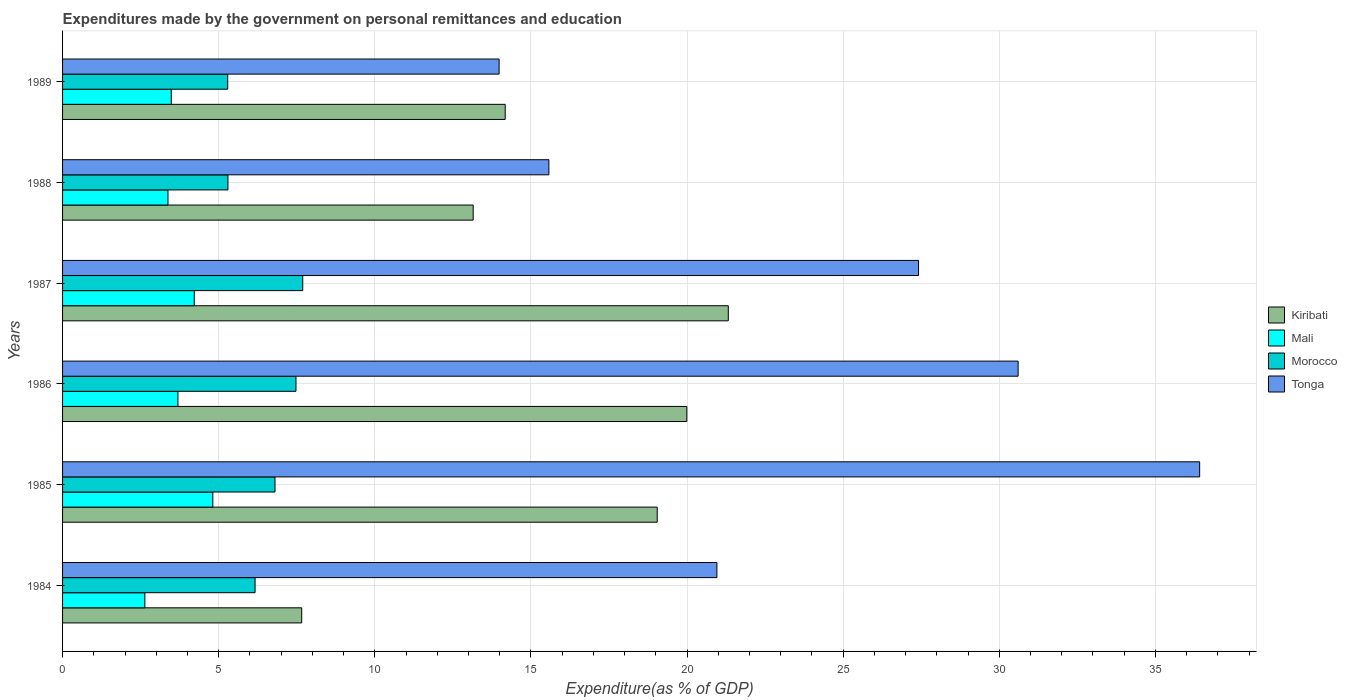How many groups of bars are there?
Your answer should be compact. 6. Are the number of bars per tick equal to the number of legend labels?
Give a very brief answer. Yes. Are the number of bars on each tick of the Y-axis equal?
Your answer should be compact. Yes. How many bars are there on the 2nd tick from the top?
Offer a very short reply. 4. How many bars are there on the 2nd tick from the bottom?
Your answer should be compact. 4. What is the label of the 3rd group of bars from the top?
Offer a terse response. 1987. What is the expenditures made by the government on personal remittances and education in Morocco in 1987?
Ensure brevity in your answer.  7.69. Across all years, what is the maximum expenditures made by the government on personal remittances and education in Mali?
Your answer should be compact. 4.81. Across all years, what is the minimum expenditures made by the government on personal remittances and education in Morocco?
Give a very brief answer. 5.29. In which year was the expenditures made by the government on personal remittances and education in Kiribati minimum?
Keep it short and to the point. 1984. What is the total expenditures made by the government on personal remittances and education in Mali in the graph?
Provide a short and direct response. 22.22. What is the difference between the expenditures made by the government on personal remittances and education in Kiribati in 1987 and that in 1989?
Keep it short and to the point. 7.14. What is the difference between the expenditures made by the government on personal remittances and education in Kiribati in 1988 and the expenditures made by the government on personal remittances and education in Mali in 1986?
Ensure brevity in your answer.  9.46. What is the average expenditures made by the government on personal remittances and education in Mali per year?
Your answer should be compact. 3.7. In the year 1986, what is the difference between the expenditures made by the government on personal remittances and education in Kiribati and expenditures made by the government on personal remittances and education in Morocco?
Make the answer very short. 12.52. In how many years, is the expenditures made by the government on personal remittances and education in Kiribati greater than 31 %?
Your answer should be very brief. 0. What is the ratio of the expenditures made by the government on personal remittances and education in Mali in 1986 to that in 1987?
Provide a succinct answer. 0.88. What is the difference between the highest and the second highest expenditures made by the government on personal remittances and education in Kiribati?
Your answer should be compact. 1.33. What is the difference between the highest and the lowest expenditures made by the government on personal remittances and education in Kiribati?
Make the answer very short. 13.66. What does the 2nd bar from the top in 1987 represents?
Provide a succinct answer. Morocco. What does the 1st bar from the bottom in 1986 represents?
Offer a very short reply. Kiribati. Are all the bars in the graph horizontal?
Your answer should be compact. Yes. How many years are there in the graph?
Keep it short and to the point. 6. Are the values on the major ticks of X-axis written in scientific E-notation?
Give a very brief answer. No. Does the graph contain any zero values?
Provide a short and direct response. No. Does the graph contain grids?
Offer a terse response. Yes. How many legend labels are there?
Your response must be concise. 4. How are the legend labels stacked?
Provide a succinct answer. Vertical. What is the title of the graph?
Keep it short and to the point. Expenditures made by the government on personal remittances and education. What is the label or title of the X-axis?
Ensure brevity in your answer.  Expenditure(as % of GDP). What is the Expenditure(as % of GDP) of Kiribati in 1984?
Ensure brevity in your answer.  7.66. What is the Expenditure(as % of GDP) in Mali in 1984?
Make the answer very short. 2.64. What is the Expenditure(as % of GDP) in Morocco in 1984?
Offer a terse response. 6.17. What is the Expenditure(as % of GDP) of Tonga in 1984?
Keep it short and to the point. 20.96. What is the Expenditure(as % of GDP) of Kiribati in 1985?
Give a very brief answer. 19.04. What is the Expenditure(as % of GDP) of Mali in 1985?
Make the answer very short. 4.81. What is the Expenditure(as % of GDP) of Morocco in 1985?
Your response must be concise. 6.8. What is the Expenditure(as % of GDP) in Tonga in 1985?
Make the answer very short. 36.42. What is the Expenditure(as % of GDP) of Kiribati in 1986?
Provide a succinct answer. 19.99. What is the Expenditure(as % of GDP) in Mali in 1986?
Give a very brief answer. 3.69. What is the Expenditure(as % of GDP) in Morocco in 1986?
Your answer should be compact. 7.48. What is the Expenditure(as % of GDP) of Tonga in 1986?
Make the answer very short. 30.6. What is the Expenditure(as % of GDP) of Kiribati in 1987?
Offer a terse response. 21.32. What is the Expenditure(as % of GDP) in Mali in 1987?
Make the answer very short. 4.22. What is the Expenditure(as % of GDP) of Morocco in 1987?
Offer a very short reply. 7.69. What is the Expenditure(as % of GDP) of Tonga in 1987?
Make the answer very short. 27.41. What is the Expenditure(as % of GDP) of Kiribati in 1988?
Provide a succinct answer. 13.15. What is the Expenditure(as % of GDP) in Mali in 1988?
Your answer should be compact. 3.38. What is the Expenditure(as % of GDP) of Morocco in 1988?
Ensure brevity in your answer.  5.3. What is the Expenditure(as % of GDP) of Tonga in 1988?
Your response must be concise. 15.58. What is the Expenditure(as % of GDP) of Kiribati in 1989?
Provide a succinct answer. 14.18. What is the Expenditure(as % of GDP) of Mali in 1989?
Your answer should be very brief. 3.48. What is the Expenditure(as % of GDP) in Morocco in 1989?
Give a very brief answer. 5.29. What is the Expenditure(as % of GDP) of Tonga in 1989?
Give a very brief answer. 13.98. Across all years, what is the maximum Expenditure(as % of GDP) in Kiribati?
Your response must be concise. 21.32. Across all years, what is the maximum Expenditure(as % of GDP) in Mali?
Offer a very short reply. 4.81. Across all years, what is the maximum Expenditure(as % of GDP) in Morocco?
Offer a terse response. 7.69. Across all years, what is the maximum Expenditure(as % of GDP) of Tonga?
Your answer should be compact. 36.42. Across all years, what is the minimum Expenditure(as % of GDP) in Kiribati?
Provide a succinct answer. 7.66. Across all years, what is the minimum Expenditure(as % of GDP) of Mali?
Provide a succinct answer. 2.64. Across all years, what is the minimum Expenditure(as % of GDP) in Morocco?
Offer a terse response. 5.29. Across all years, what is the minimum Expenditure(as % of GDP) of Tonga?
Provide a short and direct response. 13.98. What is the total Expenditure(as % of GDP) in Kiribati in the graph?
Your response must be concise. 95.34. What is the total Expenditure(as % of GDP) of Mali in the graph?
Give a very brief answer. 22.22. What is the total Expenditure(as % of GDP) in Morocco in the graph?
Your answer should be very brief. 38.72. What is the total Expenditure(as % of GDP) in Tonga in the graph?
Your answer should be compact. 144.95. What is the difference between the Expenditure(as % of GDP) of Kiribati in 1984 and that in 1985?
Ensure brevity in your answer.  -11.39. What is the difference between the Expenditure(as % of GDP) of Mali in 1984 and that in 1985?
Your answer should be very brief. -2.18. What is the difference between the Expenditure(as % of GDP) in Morocco in 1984 and that in 1985?
Keep it short and to the point. -0.64. What is the difference between the Expenditure(as % of GDP) in Tonga in 1984 and that in 1985?
Ensure brevity in your answer.  -15.46. What is the difference between the Expenditure(as % of GDP) in Kiribati in 1984 and that in 1986?
Ensure brevity in your answer.  -12.33. What is the difference between the Expenditure(as % of GDP) of Mali in 1984 and that in 1986?
Ensure brevity in your answer.  -1.06. What is the difference between the Expenditure(as % of GDP) in Morocco in 1984 and that in 1986?
Give a very brief answer. -1.31. What is the difference between the Expenditure(as % of GDP) of Tonga in 1984 and that in 1986?
Ensure brevity in your answer.  -9.65. What is the difference between the Expenditure(as % of GDP) in Kiribati in 1984 and that in 1987?
Provide a succinct answer. -13.66. What is the difference between the Expenditure(as % of GDP) of Mali in 1984 and that in 1987?
Make the answer very short. -1.58. What is the difference between the Expenditure(as % of GDP) in Morocco in 1984 and that in 1987?
Give a very brief answer. -1.53. What is the difference between the Expenditure(as % of GDP) in Tonga in 1984 and that in 1987?
Provide a succinct answer. -6.46. What is the difference between the Expenditure(as % of GDP) in Kiribati in 1984 and that in 1988?
Give a very brief answer. -5.49. What is the difference between the Expenditure(as % of GDP) of Mali in 1984 and that in 1988?
Provide a succinct answer. -0.74. What is the difference between the Expenditure(as % of GDP) of Morocco in 1984 and that in 1988?
Offer a very short reply. 0.87. What is the difference between the Expenditure(as % of GDP) in Tonga in 1984 and that in 1988?
Provide a succinct answer. 5.38. What is the difference between the Expenditure(as % of GDP) of Kiribati in 1984 and that in 1989?
Provide a short and direct response. -6.52. What is the difference between the Expenditure(as % of GDP) of Mali in 1984 and that in 1989?
Provide a succinct answer. -0.85. What is the difference between the Expenditure(as % of GDP) in Morocco in 1984 and that in 1989?
Give a very brief answer. 0.88. What is the difference between the Expenditure(as % of GDP) in Tonga in 1984 and that in 1989?
Your response must be concise. 6.98. What is the difference between the Expenditure(as % of GDP) of Kiribati in 1985 and that in 1986?
Keep it short and to the point. -0.95. What is the difference between the Expenditure(as % of GDP) in Mali in 1985 and that in 1986?
Offer a very short reply. 1.12. What is the difference between the Expenditure(as % of GDP) of Morocco in 1985 and that in 1986?
Keep it short and to the point. -0.67. What is the difference between the Expenditure(as % of GDP) of Tonga in 1985 and that in 1986?
Give a very brief answer. 5.81. What is the difference between the Expenditure(as % of GDP) of Kiribati in 1985 and that in 1987?
Your answer should be compact. -2.28. What is the difference between the Expenditure(as % of GDP) of Mali in 1985 and that in 1987?
Your answer should be compact. 0.59. What is the difference between the Expenditure(as % of GDP) in Morocco in 1985 and that in 1987?
Make the answer very short. -0.89. What is the difference between the Expenditure(as % of GDP) of Tonga in 1985 and that in 1987?
Keep it short and to the point. 9. What is the difference between the Expenditure(as % of GDP) of Kiribati in 1985 and that in 1988?
Your answer should be compact. 5.89. What is the difference between the Expenditure(as % of GDP) of Mali in 1985 and that in 1988?
Make the answer very short. 1.44. What is the difference between the Expenditure(as % of GDP) of Morocco in 1985 and that in 1988?
Your answer should be compact. 1.51. What is the difference between the Expenditure(as % of GDP) in Tonga in 1985 and that in 1988?
Offer a terse response. 20.84. What is the difference between the Expenditure(as % of GDP) in Kiribati in 1985 and that in 1989?
Your answer should be very brief. 4.87. What is the difference between the Expenditure(as % of GDP) of Mali in 1985 and that in 1989?
Provide a short and direct response. 1.33. What is the difference between the Expenditure(as % of GDP) of Morocco in 1985 and that in 1989?
Keep it short and to the point. 1.51. What is the difference between the Expenditure(as % of GDP) of Tonga in 1985 and that in 1989?
Ensure brevity in your answer.  22.44. What is the difference between the Expenditure(as % of GDP) in Kiribati in 1986 and that in 1987?
Your answer should be very brief. -1.33. What is the difference between the Expenditure(as % of GDP) in Mali in 1986 and that in 1987?
Offer a terse response. -0.52. What is the difference between the Expenditure(as % of GDP) in Morocco in 1986 and that in 1987?
Provide a succinct answer. -0.22. What is the difference between the Expenditure(as % of GDP) of Tonga in 1986 and that in 1987?
Your answer should be very brief. 3.19. What is the difference between the Expenditure(as % of GDP) in Kiribati in 1986 and that in 1988?
Offer a terse response. 6.84. What is the difference between the Expenditure(as % of GDP) of Mali in 1986 and that in 1988?
Offer a terse response. 0.32. What is the difference between the Expenditure(as % of GDP) in Morocco in 1986 and that in 1988?
Make the answer very short. 2.18. What is the difference between the Expenditure(as % of GDP) in Tonga in 1986 and that in 1988?
Offer a terse response. 15.03. What is the difference between the Expenditure(as % of GDP) in Kiribati in 1986 and that in 1989?
Ensure brevity in your answer.  5.82. What is the difference between the Expenditure(as % of GDP) in Mali in 1986 and that in 1989?
Keep it short and to the point. 0.21. What is the difference between the Expenditure(as % of GDP) of Morocco in 1986 and that in 1989?
Offer a very short reply. 2.19. What is the difference between the Expenditure(as % of GDP) of Tonga in 1986 and that in 1989?
Offer a very short reply. 16.62. What is the difference between the Expenditure(as % of GDP) in Kiribati in 1987 and that in 1988?
Your response must be concise. 8.17. What is the difference between the Expenditure(as % of GDP) of Mali in 1987 and that in 1988?
Provide a short and direct response. 0.84. What is the difference between the Expenditure(as % of GDP) in Morocco in 1987 and that in 1988?
Your response must be concise. 2.4. What is the difference between the Expenditure(as % of GDP) of Tonga in 1987 and that in 1988?
Give a very brief answer. 11.84. What is the difference between the Expenditure(as % of GDP) in Kiribati in 1987 and that in 1989?
Keep it short and to the point. 7.14. What is the difference between the Expenditure(as % of GDP) in Mali in 1987 and that in 1989?
Give a very brief answer. 0.74. What is the difference between the Expenditure(as % of GDP) in Morocco in 1987 and that in 1989?
Make the answer very short. 2.4. What is the difference between the Expenditure(as % of GDP) of Tonga in 1987 and that in 1989?
Provide a succinct answer. 13.43. What is the difference between the Expenditure(as % of GDP) of Kiribati in 1988 and that in 1989?
Offer a terse response. -1.03. What is the difference between the Expenditure(as % of GDP) in Mali in 1988 and that in 1989?
Provide a succinct answer. -0.11. What is the difference between the Expenditure(as % of GDP) of Morocco in 1988 and that in 1989?
Provide a short and direct response. 0.01. What is the difference between the Expenditure(as % of GDP) of Tonga in 1988 and that in 1989?
Give a very brief answer. 1.59. What is the difference between the Expenditure(as % of GDP) of Kiribati in 1984 and the Expenditure(as % of GDP) of Mali in 1985?
Your answer should be compact. 2.85. What is the difference between the Expenditure(as % of GDP) in Kiribati in 1984 and the Expenditure(as % of GDP) in Morocco in 1985?
Ensure brevity in your answer.  0.85. What is the difference between the Expenditure(as % of GDP) in Kiribati in 1984 and the Expenditure(as % of GDP) in Tonga in 1985?
Offer a terse response. -28.76. What is the difference between the Expenditure(as % of GDP) in Mali in 1984 and the Expenditure(as % of GDP) in Morocco in 1985?
Offer a terse response. -4.17. What is the difference between the Expenditure(as % of GDP) in Mali in 1984 and the Expenditure(as % of GDP) in Tonga in 1985?
Give a very brief answer. -33.78. What is the difference between the Expenditure(as % of GDP) of Morocco in 1984 and the Expenditure(as % of GDP) of Tonga in 1985?
Your response must be concise. -30.25. What is the difference between the Expenditure(as % of GDP) in Kiribati in 1984 and the Expenditure(as % of GDP) in Mali in 1986?
Ensure brevity in your answer.  3.96. What is the difference between the Expenditure(as % of GDP) of Kiribati in 1984 and the Expenditure(as % of GDP) of Morocco in 1986?
Offer a very short reply. 0.18. What is the difference between the Expenditure(as % of GDP) of Kiribati in 1984 and the Expenditure(as % of GDP) of Tonga in 1986?
Ensure brevity in your answer.  -22.94. What is the difference between the Expenditure(as % of GDP) of Mali in 1984 and the Expenditure(as % of GDP) of Morocco in 1986?
Ensure brevity in your answer.  -4.84. What is the difference between the Expenditure(as % of GDP) of Mali in 1984 and the Expenditure(as % of GDP) of Tonga in 1986?
Your response must be concise. -27.97. What is the difference between the Expenditure(as % of GDP) of Morocco in 1984 and the Expenditure(as % of GDP) of Tonga in 1986?
Provide a succinct answer. -24.44. What is the difference between the Expenditure(as % of GDP) in Kiribati in 1984 and the Expenditure(as % of GDP) in Mali in 1987?
Your answer should be compact. 3.44. What is the difference between the Expenditure(as % of GDP) in Kiribati in 1984 and the Expenditure(as % of GDP) in Morocco in 1987?
Provide a succinct answer. -0.03. What is the difference between the Expenditure(as % of GDP) of Kiribati in 1984 and the Expenditure(as % of GDP) of Tonga in 1987?
Ensure brevity in your answer.  -19.76. What is the difference between the Expenditure(as % of GDP) of Mali in 1984 and the Expenditure(as % of GDP) of Morocco in 1987?
Your answer should be very brief. -5.06. What is the difference between the Expenditure(as % of GDP) in Mali in 1984 and the Expenditure(as % of GDP) in Tonga in 1987?
Your answer should be compact. -24.78. What is the difference between the Expenditure(as % of GDP) of Morocco in 1984 and the Expenditure(as % of GDP) of Tonga in 1987?
Keep it short and to the point. -21.25. What is the difference between the Expenditure(as % of GDP) in Kiribati in 1984 and the Expenditure(as % of GDP) in Mali in 1988?
Your response must be concise. 4.28. What is the difference between the Expenditure(as % of GDP) of Kiribati in 1984 and the Expenditure(as % of GDP) of Morocco in 1988?
Give a very brief answer. 2.36. What is the difference between the Expenditure(as % of GDP) in Kiribati in 1984 and the Expenditure(as % of GDP) in Tonga in 1988?
Keep it short and to the point. -7.92. What is the difference between the Expenditure(as % of GDP) in Mali in 1984 and the Expenditure(as % of GDP) in Morocco in 1988?
Make the answer very short. -2.66. What is the difference between the Expenditure(as % of GDP) in Mali in 1984 and the Expenditure(as % of GDP) in Tonga in 1988?
Keep it short and to the point. -12.94. What is the difference between the Expenditure(as % of GDP) in Morocco in 1984 and the Expenditure(as % of GDP) in Tonga in 1988?
Your answer should be very brief. -9.41. What is the difference between the Expenditure(as % of GDP) in Kiribati in 1984 and the Expenditure(as % of GDP) in Mali in 1989?
Ensure brevity in your answer.  4.18. What is the difference between the Expenditure(as % of GDP) in Kiribati in 1984 and the Expenditure(as % of GDP) in Morocco in 1989?
Your response must be concise. 2.37. What is the difference between the Expenditure(as % of GDP) in Kiribati in 1984 and the Expenditure(as % of GDP) in Tonga in 1989?
Your answer should be compact. -6.32. What is the difference between the Expenditure(as % of GDP) in Mali in 1984 and the Expenditure(as % of GDP) in Morocco in 1989?
Make the answer very short. -2.65. What is the difference between the Expenditure(as % of GDP) of Mali in 1984 and the Expenditure(as % of GDP) of Tonga in 1989?
Offer a very short reply. -11.34. What is the difference between the Expenditure(as % of GDP) in Morocco in 1984 and the Expenditure(as % of GDP) in Tonga in 1989?
Provide a succinct answer. -7.82. What is the difference between the Expenditure(as % of GDP) in Kiribati in 1985 and the Expenditure(as % of GDP) in Mali in 1986?
Provide a short and direct response. 15.35. What is the difference between the Expenditure(as % of GDP) of Kiribati in 1985 and the Expenditure(as % of GDP) of Morocco in 1986?
Give a very brief answer. 11.57. What is the difference between the Expenditure(as % of GDP) in Kiribati in 1985 and the Expenditure(as % of GDP) in Tonga in 1986?
Give a very brief answer. -11.56. What is the difference between the Expenditure(as % of GDP) in Mali in 1985 and the Expenditure(as % of GDP) in Morocco in 1986?
Your answer should be very brief. -2.66. What is the difference between the Expenditure(as % of GDP) of Mali in 1985 and the Expenditure(as % of GDP) of Tonga in 1986?
Ensure brevity in your answer.  -25.79. What is the difference between the Expenditure(as % of GDP) in Morocco in 1985 and the Expenditure(as % of GDP) in Tonga in 1986?
Offer a terse response. -23.8. What is the difference between the Expenditure(as % of GDP) in Kiribati in 1985 and the Expenditure(as % of GDP) in Mali in 1987?
Offer a terse response. 14.83. What is the difference between the Expenditure(as % of GDP) in Kiribati in 1985 and the Expenditure(as % of GDP) in Morocco in 1987?
Provide a short and direct response. 11.35. What is the difference between the Expenditure(as % of GDP) of Kiribati in 1985 and the Expenditure(as % of GDP) of Tonga in 1987?
Provide a short and direct response. -8.37. What is the difference between the Expenditure(as % of GDP) in Mali in 1985 and the Expenditure(as % of GDP) in Morocco in 1987?
Give a very brief answer. -2.88. What is the difference between the Expenditure(as % of GDP) of Mali in 1985 and the Expenditure(as % of GDP) of Tonga in 1987?
Provide a short and direct response. -22.6. What is the difference between the Expenditure(as % of GDP) of Morocco in 1985 and the Expenditure(as % of GDP) of Tonga in 1987?
Offer a terse response. -20.61. What is the difference between the Expenditure(as % of GDP) in Kiribati in 1985 and the Expenditure(as % of GDP) in Mali in 1988?
Your answer should be very brief. 15.67. What is the difference between the Expenditure(as % of GDP) of Kiribati in 1985 and the Expenditure(as % of GDP) of Morocco in 1988?
Provide a short and direct response. 13.75. What is the difference between the Expenditure(as % of GDP) of Kiribati in 1985 and the Expenditure(as % of GDP) of Tonga in 1988?
Make the answer very short. 3.47. What is the difference between the Expenditure(as % of GDP) in Mali in 1985 and the Expenditure(as % of GDP) in Morocco in 1988?
Keep it short and to the point. -0.48. What is the difference between the Expenditure(as % of GDP) in Mali in 1985 and the Expenditure(as % of GDP) in Tonga in 1988?
Ensure brevity in your answer.  -10.76. What is the difference between the Expenditure(as % of GDP) of Morocco in 1985 and the Expenditure(as % of GDP) of Tonga in 1988?
Your answer should be very brief. -8.77. What is the difference between the Expenditure(as % of GDP) in Kiribati in 1985 and the Expenditure(as % of GDP) in Mali in 1989?
Offer a very short reply. 15.56. What is the difference between the Expenditure(as % of GDP) of Kiribati in 1985 and the Expenditure(as % of GDP) of Morocco in 1989?
Your answer should be compact. 13.76. What is the difference between the Expenditure(as % of GDP) of Kiribati in 1985 and the Expenditure(as % of GDP) of Tonga in 1989?
Your answer should be compact. 5.06. What is the difference between the Expenditure(as % of GDP) of Mali in 1985 and the Expenditure(as % of GDP) of Morocco in 1989?
Make the answer very short. -0.48. What is the difference between the Expenditure(as % of GDP) of Mali in 1985 and the Expenditure(as % of GDP) of Tonga in 1989?
Offer a very short reply. -9.17. What is the difference between the Expenditure(as % of GDP) of Morocco in 1985 and the Expenditure(as % of GDP) of Tonga in 1989?
Provide a short and direct response. -7.18. What is the difference between the Expenditure(as % of GDP) of Kiribati in 1986 and the Expenditure(as % of GDP) of Mali in 1987?
Make the answer very short. 15.77. What is the difference between the Expenditure(as % of GDP) in Kiribati in 1986 and the Expenditure(as % of GDP) in Morocco in 1987?
Provide a short and direct response. 12.3. What is the difference between the Expenditure(as % of GDP) of Kiribati in 1986 and the Expenditure(as % of GDP) of Tonga in 1987?
Provide a succinct answer. -7.42. What is the difference between the Expenditure(as % of GDP) in Mali in 1986 and the Expenditure(as % of GDP) in Morocco in 1987?
Give a very brief answer. -4. What is the difference between the Expenditure(as % of GDP) of Mali in 1986 and the Expenditure(as % of GDP) of Tonga in 1987?
Ensure brevity in your answer.  -23.72. What is the difference between the Expenditure(as % of GDP) of Morocco in 1986 and the Expenditure(as % of GDP) of Tonga in 1987?
Give a very brief answer. -19.94. What is the difference between the Expenditure(as % of GDP) in Kiribati in 1986 and the Expenditure(as % of GDP) in Mali in 1988?
Your answer should be compact. 16.62. What is the difference between the Expenditure(as % of GDP) of Kiribati in 1986 and the Expenditure(as % of GDP) of Morocco in 1988?
Your answer should be compact. 14.7. What is the difference between the Expenditure(as % of GDP) in Kiribati in 1986 and the Expenditure(as % of GDP) in Tonga in 1988?
Offer a terse response. 4.42. What is the difference between the Expenditure(as % of GDP) in Mali in 1986 and the Expenditure(as % of GDP) in Morocco in 1988?
Your answer should be very brief. -1.6. What is the difference between the Expenditure(as % of GDP) of Mali in 1986 and the Expenditure(as % of GDP) of Tonga in 1988?
Ensure brevity in your answer.  -11.88. What is the difference between the Expenditure(as % of GDP) in Morocco in 1986 and the Expenditure(as % of GDP) in Tonga in 1988?
Your response must be concise. -8.1. What is the difference between the Expenditure(as % of GDP) in Kiribati in 1986 and the Expenditure(as % of GDP) in Mali in 1989?
Ensure brevity in your answer.  16.51. What is the difference between the Expenditure(as % of GDP) of Kiribati in 1986 and the Expenditure(as % of GDP) of Morocco in 1989?
Make the answer very short. 14.7. What is the difference between the Expenditure(as % of GDP) of Kiribati in 1986 and the Expenditure(as % of GDP) of Tonga in 1989?
Your response must be concise. 6.01. What is the difference between the Expenditure(as % of GDP) in Mali in 1986 and the Expenditure(as % of GDP) in Morocco in 1989?
Ensure brevity in your answer.  -1.59. What is the difference between the Expenditure(as % of GDP) in Mali in 1986 and the Expenditure(as % of GDP) in Tonga in 1989?
Provide a short and direct response. -10.29. What is the difference between the Expenditure(as % of GDP) in Morocco in 1986 and the Expenditure(as % of GDP) in Tonga in 1989?
Give a very brief answer. -6.5. What is the difference between the Expenditure(as % of GDP) in Kiribati in 1987 and the Expenditure(as % of GDP) in Mali in 1988?
Ensure brevity in your answer.  17.94. What is the difference between the Expenditure(as % of GDP) in Kiribati in 1987 and the Expenditure(as % of GDP) in Morocco in 1988?
Offer a very short reply. 16.02. What is the difference between the Expenditure(as % of GDP) of Kiribati in 1987 and the Expenditure(as % of GDP) of Tonga in 1988?
Make the answer very short. 5.75. What is the difference between the Expenditure(as % of GDP) in Mali in 1987 and the Expenditure(as % of GDP) in Morocco in 1988?
Your response must be concise. -1.08. What is the difference between the Expenditure(as % of GDP) of Mali in 1987 and the Expenditure(as % of GDP) of Tonga in 1988?
Your response must be concise. -11.36. What is the difference between the Expenditure(as % of GDP) in Morocco in 1987 and the Expenditure(as % of GDP) in Tonga in 1988?
Make the answer very short. -7.88. What is the difference between the Expenditure(as % of GDP) of Kiribati in 1987 and the Expenditure(as % of GDP) of Mali in 1989?
Offer a very short reply. 17.84. What is the difference between the Expenditure(as % of GDP) in Kiribati in 1987 and the Expenditure(as % of GDP) in Morocco in 1989?
Provide a short and direct response. 16.03. What is the difference between the Expenditure(as % of GDP) of Kiribati in 1987 and the Expenditure(as % of GDP) of Tonga in 1989?
Your answer should be compact. 7.34. What is the difference between the Expenditure(as % of GDP) of Mali in 1987 and the Expenditure(as % of GDP) of Morocco in 1989?
Your answer should be compact. -1.07. What is the difference between the Expenditure(as % of GDP) of Mali in 1987 and the Expenditure(as % of GDP) of Tonga in 1989?
Offer a terse response. -9.76. What is the difference between the Expenditure(as % of GDP) of Morocco in 1987 and the Expenditure(as % of GDP) of Tonga in 1989?
Keep it short and to the point. -6.29. What is the difference between the Expenditure(as % of GDP) in Kiribati in 1988 and the Expenditure(as % of GDP) in Mali in 1989?
Give a very brief answer. 9.67. What is the difference between the Expenditure(as % of GDP) in Kiribati in 1988 and the Expenditure(as % of GDP) in Morocco in 1989?
Provide a succinct answer. 7.86. What is the difference between the Expenditure(as % of GDP) in Kiribati in 1988 and the Expenditure(as % of GDP) in Tonga in 1989?
Keep it short and to the point. -0.83. What is the difference between the Expenditure(as % of GDP) of Mali in 1988 and the Expenditure(as % of GDP) of Morocco in 1989?
Ensure brevity in your answer.  -1.91. What is the difference between the Expenditure(as % of GDP) of Mali in 1988 and the Expenditure(as % of GDP) of Tonga in 1989?
Ensure brevity in your answer.  -10.6. What is the difference between the Expenditure(as % of GDP) of Morocco in 1988 and the Expenditure(as % of GDP) of Tonga in 1989?
Make the answer very short. -8.68. What is the average Expenditure(as % of GDP) in Kiribati per year?
Your answer should be very brief. 15.89. What is the average Expenditure(as % of GDP) of Mali per year?
Offer a very short reply. 3.7. What is the average Expenditure(as % of GDP) in Morocco per year?
Make the answer very short. 6.45. What is the average Expenditure(as % of GDP) of Tonga per year?
Ensure brevity in your answer.  24.16. In the year 1984, what is the difference between the Expenditure(as % of GDP) in Kiribati and Expenditure(as % of GDP) in Mali?
Your answer should be compact. 5.02. In the year 1984, what is the difference between the Expenditure(as % of GDP) of Kiribati and Expenditure(as % of GDP) of Morocco?
Your response must be concise. 1.49. In the year 1984, what is the difference between the Expenditure(as % of GDP) of Kiribati and Expenditure(as % of GDP) of Tonga?
Offer a terse response. -13.3. In the year 1984, what is the difference between the Expenditure(as % of GDP) of Mali and Expenditure(as % of GDP) of Morocco?
Ensure brevity in your answer.  -3.53. In the year 1984, what is the difference between the Expenditure(as % of GDP) in Mali and Expenditure(as % of GDP) in Tonga?
Your answer should be compact. -18.32. In the year 1984, what is the difference between the Expenditure(as % of GDP) in Morocco and Expenditure(as % of GDP) in Tonga?
Provide a short and direct response. -14.79. In the year 1985, what is the difference between the Expenditure(as % of GDP) of Kiribati and Expenditure(as % of GDP) of Mali?
Provide a succinct answer. 14.23. In the year 1985, what is the difference between the Expenditure(as % of GDP) in Kiribati and Expenditure(as % of GDP) in Morocco?
Offer a very short reply. 12.24. In the year 1985, what is the difference between the Expenditure(as % of GDP) of Kiribati and Expenditure(as % of GDP) of Tonga?
Ensure brevity in your answer.  -17.37. In the year 1985, what is the difference between the Expenditure(as % of GDP) of Mali and Expenditure(as % of GDP) of Morocco?
Provide a succinct answer. -1.99. In the year 1985, what is the difference between the Expenditure(as % of GDP) in Mali and Expenditure(as % of GDP) in Tonga?
Offer a very short reply. -31.6. In the year 1985, what is the difference between the Expenditure(as % of GDP) of Morocco and Expenditure(as % of GDP) of Tonga?
Offer a very short reply. -29.61. In the year 1986, what is the difference between the Expenditure(as % of GDP) in Kiribati and Expenditure(as % of GDP) in Mali?
Your answer should be compact. 16.3. In the year 1986, what is the difference between the Expenditure(as % of GDP) in Kiribati and Expenditure(as % of GDP) in Morocco?
Give a very brief answer. 12.52. In the year 1986, what is the difference between the Expenditure(as % of GDP) of Kiribati and Expenditure(as % of GDP) of Tonga?
Provide a short and direct response. -10.61. In the year 1986, what is the difference between the Expenditure(as % of GDP) in Mali and Expenditure(as % of GDP) in Morocco?
Keep it short and to the point. -3.78. In the year 1986, what is the difference between the Expenditure(as % of GDP) in Mali and Expenditure(as % of GDP) in Tonga?
Your answer should be compact. -26.91. In the year 1986, what is the difference between the Expenditure(as % of GDP) in Morocco and Expenditure(as % of GDP) in Tonga?
Provide a short and direct response. -23.13. In the year 1987, what is the difference between the Expenditure(as % of GDP) in Kiribati and Expenditure(as % of GDP) in Mali?
Offer a terse response. 17.1. In the year 1987, what is the difference between the Expenditure(as % of GDP) in Kiribati and Expenditure(as % of GDP) in Morocco?
Provide a succinct answer. 13.63. In the year 1987, what is the difference between the Expenditure(as % of GDP) in Kiribati and Expenditure(as % of GDP) in Tonga?
Offer a very short reply. -6.09. In the year 1987, what is the difference between the Expenditure(as % of GDP) of Mali and Expenditure(as % of GDP) of Morocco?
Your answer should be compact. -3.47. In the year 1987, what is the difference between the Expenditure(as % of GDP) of Mali and Expenditure(as % of GDP) of Tonga?
Offer a very short reply. -23.2. In the year 1987, what is the difference between the Expenditure(as % of GDP) in Morocco and Expenditure(as % of GDP) in Tonga?
Your answer should be compact. -19.72. In the year 1988, what is the difference between the Expenditure(as % of GDP) of Kiribati and Expenditure(as % of GDP) of Mali?
Provide a short and direct response. 9.77. In the year 1988, what is the difference between the Expenditure(as % of GDP) in Kiribati and Expenditure(as % of GDP) in Morocco?
Provide a short and direct response. 7.85. In the year 1988, what is the difference between the Expenditure(as % of GDP) in Kiribati and Expenditure(as % of GDP) in Tonga?
Your answer should be compact. -2.43. In the year 1988, what is the difference between the Expenditure(as % of GDP) in Mali and Expenditure(as % of GDP) in Morocco?
Provide a short and direct response. -1.92. In the year 1988, what is the difference between the Expenditure(as % of GDP) in Mali and Expenditure(as % of GDP) in Tonga?
Give a very brief answer. -12.2. In the year 1988, what is the difference between the Expenditure(as % of GDP) of Morocco and Expenditure(as % of GDP) of Tonga?
Keep it short and to the point. -10.28. In the year 1989, what is the difference between the Expenditure(as % of GDP) in Kiribati and Expenditure(as % of GDP) in Mali?
Provide a short and direct response. 10.69. In the year 1989, what is the difference between the Expenditure(as % of GDP) in Kiribati and Expenditure(as % of GDP) in Morocco?
Your response must be concise. 8.89. In the year 1989, what is the difference between the Expenditure(as % of GDP) of Kiribati and Expenditure(as % of GDP) of Tonga?
Your answer should be compact. 0.2. In the year 1989, what is the difference between the Expenditure(as % of GDP) of Mali and Expenditure(as % of GDP) of Morocco?
Offer a very short reply. -1.81. In the year 1989, what is the difference between the Expenditure(as % of GDP) of Mali and Expenditure(as % of GDP) of Tonga?
Ensure brevity in your answer.  -10.5. In the year 1989, what is the difference between the Expenditure(as % of GDP) in Morocco and Expenditure(as % of GDP) in Tonga?
Keep it short and to the point. -8.69. What is the ratio of the Expenditure(as % of GDP) in Kiribati in 1984 to that in 1985?
Provide a succinct answer. 0.4. What is the ratio of the Expenditure(as % of GDP) of Mali in 1984 to that in 1985?
Offer a very short reply. 0.55. What is the ratio of the Expenditure(as % of GDP) in Morocco in 1984 to that in 1985?
Give a very brief answer. 0.91. What is the ratio of the Expenditure(as % of GDP) in Tonga in 1984 to that in 1985?
Offer a terse response. 0.58. What is the ratio of the Expenditure(as % of GDP) in Kiribati in 1984 to that in 1986?
Your response must be concise. 0.38. What is the ratio of the Expenditure(as % of GDP) in Mali in 1984 to that in 1986?
Your answer should be very brief. 0.71. What is the ratio of the Expenditure(as % of GDP) in Morocco in 1984 to that in 1986?
Provide a succinct answer. 0.82. What is the ratio of the Expenditure(as % of GDP) in Tonga in 1984 to that in 1986?
Ensure brevity in your answer.  0.68. What is the ratio of the Expenditure(as % of GDP) in Kiribati in 1984 to that in 1987?
Ensure brevity in your answer.  0.36. What is the ratio of the Expenditure(as % of GDP) of Mali in 1984 to that in 1987?
Keep it short and to the point. 0.62. What is the ratio of the Expenditure(as % of GDP) of Morocco in 1984 to that in 1987?
Ensure brevity in your answer.  0.8. What is the ratio of the Expenditure(as % of GDP) in Tonga in 1984 to that in 1987?
Keep it short and to the point. 0.76. What is the ratio of the Expenditure(as % of GDP) in Kiribati in 1984 to that in 1988?
Your response must be concise. 0.58. What is the ratio of the Expenditure(as % of GDP) of Mali in 1984 to that in 1988?
Your response must be concise. 0.78. What is the ratio of the Expenditure(as % of GDP) of Morocco in 1984 to that in 1988?
Offer a very short reply. 1.16. What is the ratio of the Expenditure(as % of GDP) of Tonga in 1984 to that in 1988?
Give a very brief answer. 1.35. What is the ratio of the Expenditure(as % of GDP) of Kiribati in 1984 to that in 1989?
Offer a terse response. 0.54. What is the ratio of the Expenditure(as % of GDP) in Mali in 1984 to that in 1989?
Your answer should be compact. 0.76. What is the ratio of the Expenditure(as % of GDP) of Morocco in 1984 to that in 1989?
Provide a succinct answer. 1.17. What is the ratio of the Expenditure(as % of GDP) in Tonga in 1984 to that in 1989?
Offer a terse response. 1.5. What is the ratio of the Expenditure(as % of GDP) in Kiribati in 1985 to that in 1986?
Your response must be concise. 0.95. What is the ratio of the Expenditure(as % of GDP) in Mali in 1985 to that in 1986?
Make the answer very short. 1.3. What is the ratio of the Expenditure(as % of GDP) in Morocco in 1985 to that in 1986?
Your answer should be very brief. 0.91. What is the ratio of the Expenditure(as % of GDP) of Tonga in 1985 to that in 1986?
Keep it short and to the point. 1.19. What is the ratio of the Expenditure(as % of GDP) in Kiribati in 1985 to that in 1987?
Keep it short and to the point. 0.89. What is the ratio of the Expenditure(as % of GDP) in Mali in 1985 to that in 1987?
Your response must be concise. 1.14. What is the ratio of the Expenditure(as % of GDP) in Morocco in 1985 to that in 1987?
Keep it short and to the point. 0.88. What is the ratio of the Expenditure(as % of GDP) in Tonga in 1985 to that in 1987?
Your answer should be very brief. 1.33. What is the ratio of the Expenditure(as % of GDP) of Kiribati in 1985 to that in 1988?
Provide a short and direct response. 1.45. What is the ratio of the Expenditure(as % of GDP) in Mali in 1985 to that in 1988?
Ensure brevity in your answer.  1.43. What is the ratio of the Expenditure(as % of GDP) in Morocco in 1985 to that in 1988?
Make the answer very short. 1.28. What is the ratio of the Expenditure(as % of GDP) in Tonga in 1985 to that in 1988?
Your answer should be very brief. 2.34. What is the ratio of the Expenditure(as % of GDP) of Kiribati in 1985 to that in 1989?
Make the answer very short. 1.34. What is the ratio of the Expenditure(as % of GDP) in Mali in 1985 to that in 1989?
Your answer should be compact. 1.38. What is the ratio of the Expenditure(as % of GDP) of Morocco in 1985 to that in 1989?
Keep it short and to the point. 1.29. What is the ratio of the Expenditure(as % of GDP) in Tonga in 1985 to that in 1989?
Keep it short and to the point. 2.6. What is the ratio of the Expenditure(as % of GDP) in Kiribati in 1986 to that in 1987?
Your answer should be compact. 0.94. What is the ratio of the Expenditure(as % of GDP) of Mali in 1986 to that in 1987?
Offer a very short reply. 0.88. What is the ratio of the Expenditure(as % of GDP) in Morocco in 1986 to that in 1987?
Offer a terse response. 0.97. What is the ratio of the Expenditure(as % of GDP) of Tonga in 1986 to that in 1987?
Keep it short and to the point. 1.12. What is the ratio of the Expenditure(as % of GDP) in Kiribati in 1986 to that in 1988?
Your answer should be compact. 1.52. What is the ratio of the Expenditure(as % of GDP) of Mali in 1986 to that in 1988?
Provide a short and direct response. 1.09. What is the ratio of the Expenditure(as % of GDP) of Morocco in 1986 to that in 1988?
Your answer should be very brief. 1.41. What is the ratio of the Expenditure(as % of GDP) of Tonga in 1986 to that in 1988?
Your answer should be very brief. 1.96. What is the ratio of the Expenditure(as % of GDP) of Kiribati in 1986 to that in 1989?
Provide a succinct answer. 1.41. What is the ratio of the Expenditure(as % of GDP) of Mali in 1986 to that in 1989?
Provide a succinct answer. 1.06. What is the ratio of the Expenditure(as % of GDP) in Morocco in 1986 to that in 1989?
Give a very brief answer. 1.41. What is the ratio of the Expenditure(as % of GDP) in Tonga in 1986 to that in 1989?
Give a very brief answer. 2.19. What is the ratio of the Expenditure(as % of GDP) in Kiribati in 1987 to that in 1988?
Provide a short and direct response. 1.62. What is the ratio of the Expenditure(as % of GDP) in Mali in 1987 to that in 1988?
Your response must be concise. 1.25. What is the ratio of the Expenditure(as % of GDP) in Morocco in 1987 to that in 1988?
Your answer should be very brief. 1.45. What is the ratio of the Expenditure(as % of GDP) in Tonga in 1987 to that in 1988?
Provide a succinct answer. 1.76. What is the ratio of the Expenditure(as % of GDP) in Kiribati in 1987 to that in 1989?
Give a very brief answer. 1.5. What is the ratio of the Expenditure(as % of GDP) of Mali in 1987 to that in 1989?
Offer a very short reply. 1.21. What is the ratio of the Expenditure(as % of GDP) of Morocco in 1987 to that in 1989?
Your answer should be very brief. 1.45. What is the ratio of the Expenditure(as % of GDP) of Tonga in 1987 to that in 1989?
Ensure brevity in your answer.  1.96. What is the ratio of the Expenditure(as % of GDP) in Kiribati in 1988 to that in 1989?
Offer a terse response. 0.93. What is the ratio of the Expenditure(as % of GDP) in Mali in 1988 to that in 1989?
Your response must be concise. 0.97. What is the ratio of the Expenditure(as % of GDP) in Tonga in 1988 to that in 1989?
Your answer should be compact. 1.11. What is the difference between the highest and the second highest Expenditure(as % of GDP) of Kiribati?
Ensure brevity in your answer.  1.33. What is the difference between the highest and the second highest Expenditure(as % of GDP) of Mali?
Ensure brevity in your answer.  0.59. What is the difference between the highest and the second highest Expenditure(as % of GDP) of Morocco?
Offer a very short reply. 0.22. What is the difference between the highest and the second highest Expenditure(as % of GDP) of Tonga?
Your answer should be compact. 5.81. What is the difference between the highest and the lowest Expenditure(as % of GDP) in Kiribati?
Your answer should be compact. 13.66. What is the difference between the highest and the lowest Expenditure(as % of GDP) of Mali?
Ensure brevity in your answer.  2.18. What is the difference between the highest and the lowest Expenditure(as % of GDP) in Morocco?
Offer a terse response. 2.4. What is the difference between the highest and the lowest Expenditure(as % of GDP) in Tonga?
Offer a terse response. 22.44. 